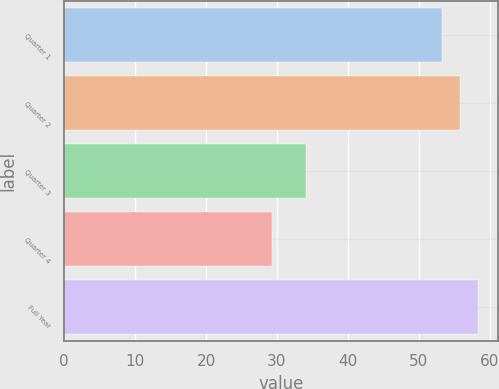Convert chart to OTSL. <chart><loc_0><loc_0><loc_500><loc_500><bar_chart><fcel>Quarter 1<fcel>Quarter 2<fcel>Quarter 3<fcel>Quarter 4<fcel>Full Year<nl><fcel>53.31<fcel>55.79<fcel>34.07<fcel>29.34<fcel>58.27<nl></chart> 